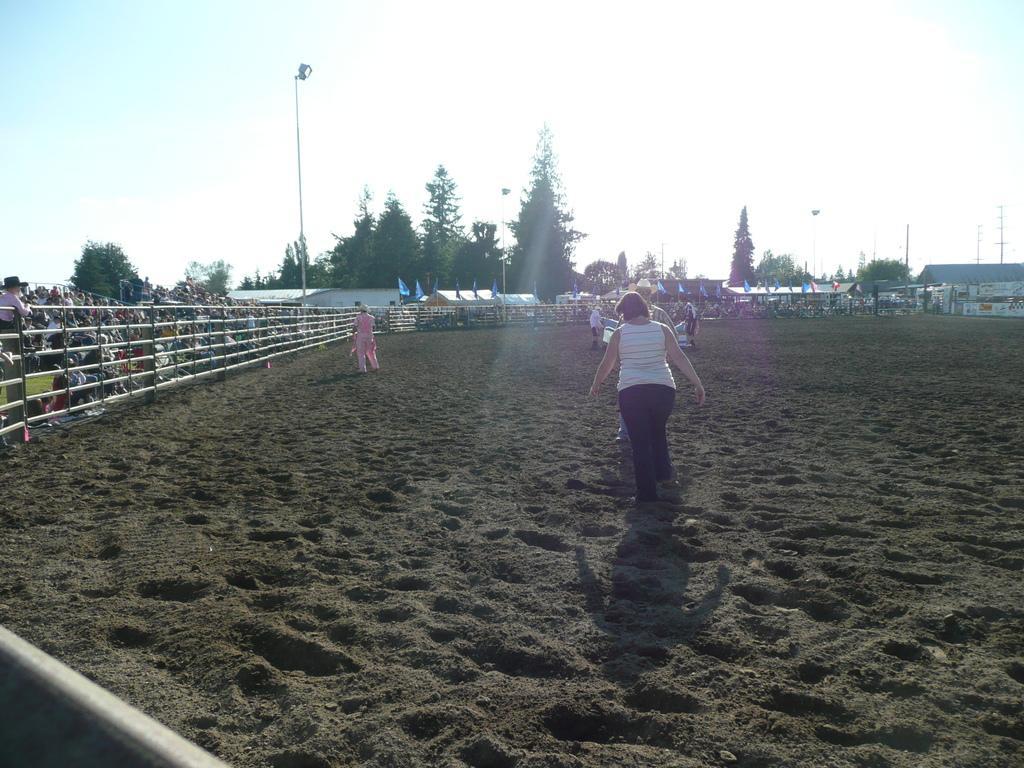Could you give a brief overview of what you see in this image? In the image I can see some people on the sand and to the side there is a fencing and also I can see some people, poles, trees and some houses. 